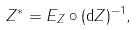<formula> <loc_0><loc_0><loc_500><loc_500>Z ^ { * } = E _ { Z } \circ ( \mathrm d Z ) ^ { - 1 } ,</formula> 